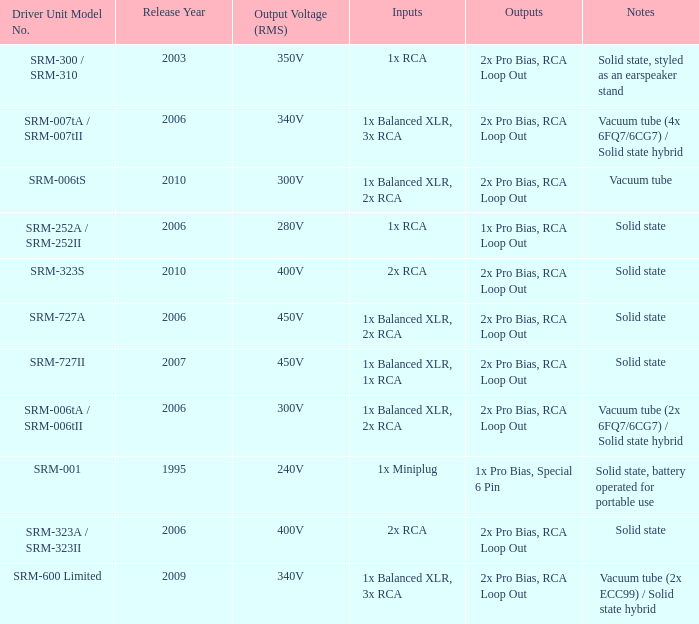What year were outputs is 2x pro bias, rca loop out and notes is vacuum tube released? 2010.0. 